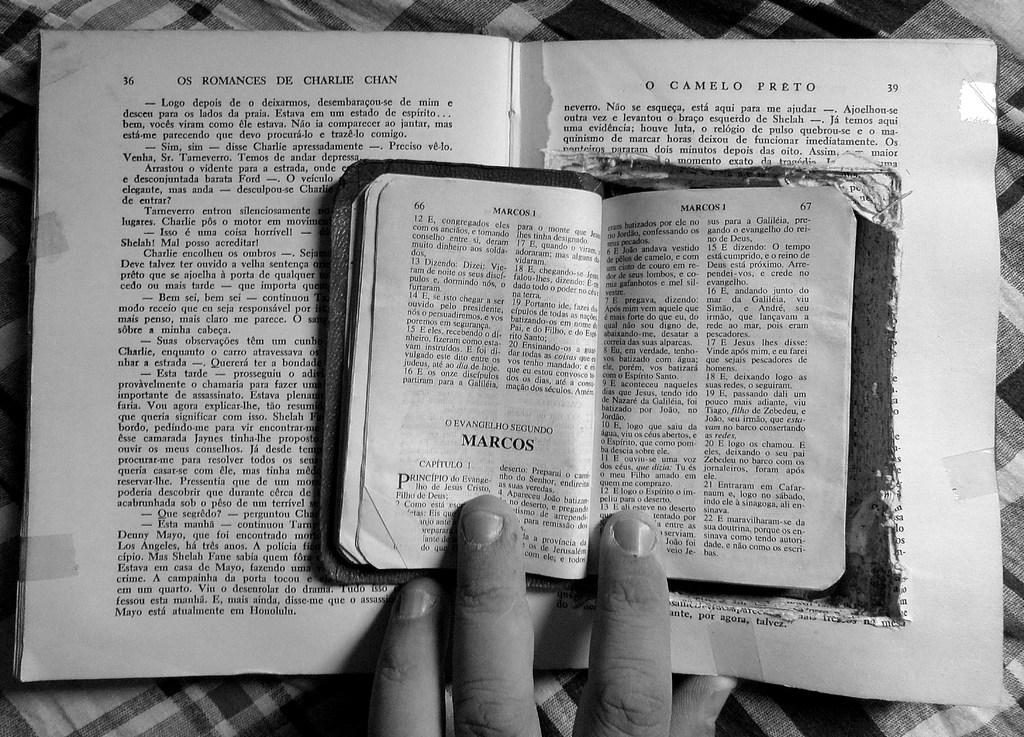Provide a one-sentence caption for the provided image. A book is open to page 66 and is titled Marcos. 